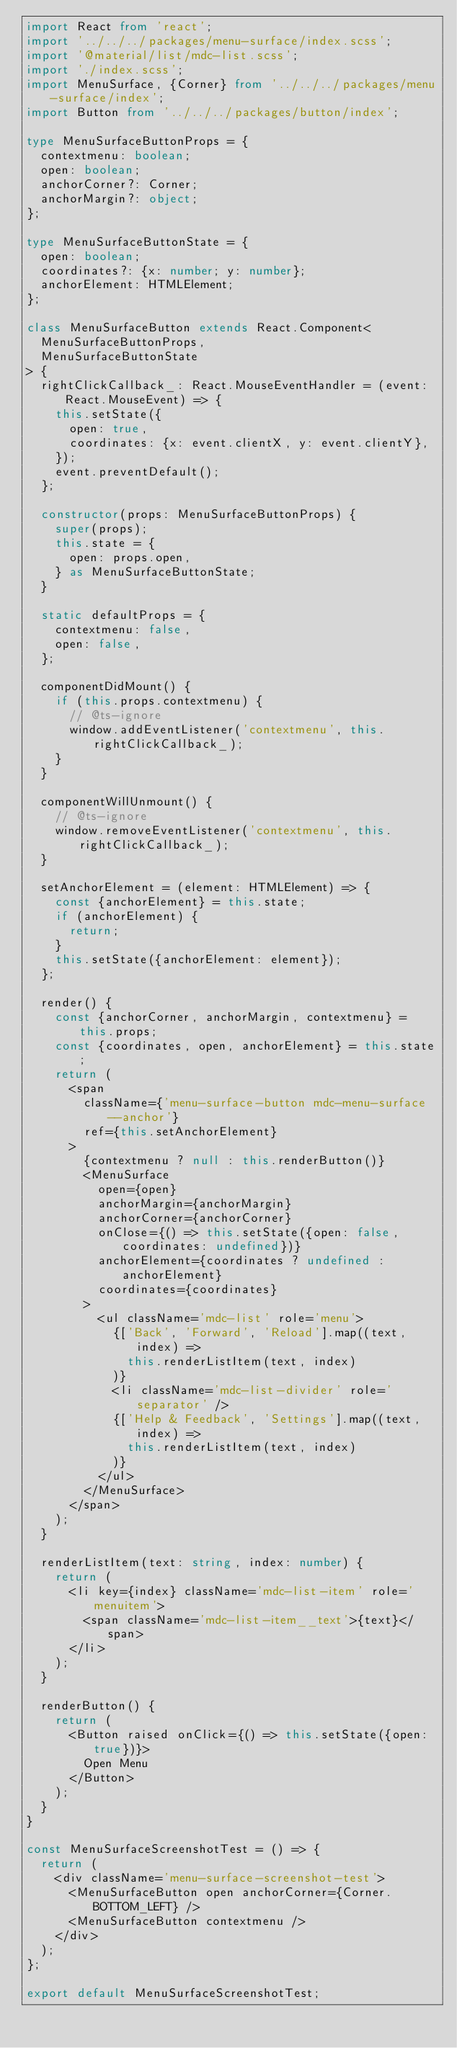<code> <loc_0><loc_0><loc_500><loc_500><_TypeScript_>import React from 'react';
import '../../../packages/menu-surface/index.scss';
import '@material/list/mdc-list.scss';
import './index.scss';
import MenuSurface, {Corner} from '../../../packages/menu-surface/index';
import Button from '../../../packages/button/index';

type MenuSurfaceButtonProps = {
  contextmenu: boolean;
  open: boolean;
  anchorCorner?: Corner;
  anchorMargin?: object;
};

type MenuSurfaceButtonState = {
  open: boolean;
  coordinates?: {x: number; y: number};
  anchorElement: HTMLElement;
};

class MenuSurfaceButton extends React.Component<
  MenuSurfaceButtonProps,
  MenuSurfaceButtonState
> {
  rightClickCallback_: React.MouseEventHandler = (event: React.MouseEvent) => {
    this.setState({
      open: true,
      coordinates: {x: event.clientX, y: event.clientY},
    });
    event.preventDefault();
  };

  constructor(props: MenuSurfaceButtonProps) {
    super(props);
    this.state = {
      open: props.open,
    } as MenuSurfaceButtonState;
  }

  static defaultProps = {
    contextmenu: false,
    open: false,
  };

  componentDidMount() {
    if (this.props.contextmenu) {
      // @ts-ignore
      window.addEventListener('contextmenu', this.rightClickCallback_);
    }
  }

  componentWillUnmount() {
    // @ts-ignore
    window.removeEventListener('contextmenu', this.rightClickCallback_);
  }

  setAnchorElement = (element: HTMLElement) => {
    const {anchorElement} = this.state;
    if (anchorElement) {
      return;
    }
    this.setState({anchorElement: element});
  };

  render() {
    const {anchorCorner, anchorMargin, contextmenu} = this.props;
    const {coordinates, open, anchorElement} = this.state;
    return (
      <span
        className={'menu-surface-button mdc-menu-surface--anchor'}
        ref={this.setAnchorElement}
      >
        {contextmenu ? null : this.renderButton()}
        <MenuSurface
          open={open}
          anchorMargin={anchorMargin}
          anchorCorner={anchorCorner}
          onClose={() => this.setState({open: false, coordinates: undefined})}
          anchorElement={coordinates ? undefined : anchorElement}
          coordinates={coordinates}
        >
          <ul className='mdc-list' role='menu'>
            {['Back', 'Forward', 'Reload'].map((text, index) =>
              this.renderListItem(text, index)
            )}
            <li className='mdc-list-divider' role='separator' />
            {['Help & Feedback', 'Settings'].map((text, index) =>
              this.renderListItem(text, index)
            )}
          </ul>
        </MenuSurface>
      </span>
    );
  }

  renderListItem(text: string, index: number) {
    return (
      <li key={index} className='mdc-list-item' role='menuitem'>
        <span className='mdc-list-item__text'>{text}</span>
      </li>
    );
  }

  renderButton() {
    return (
      <Button raised onClick={() => this.setState({open: true})}>
        Open Menu
      </Button>
    );
  }
}

const MenuSurfaceScreenshotTest = () => {
  return (
    <div className='menu-surface-screenshot-test'>
      <MenuSurfaceButton open anchorCorner={Corner.BOTTOM_LEFT} />
      <MenuSurfaceButton contextmenu />
    </div>
  );
};

export default MenuSurfaceScreenshotTest;
</code> 